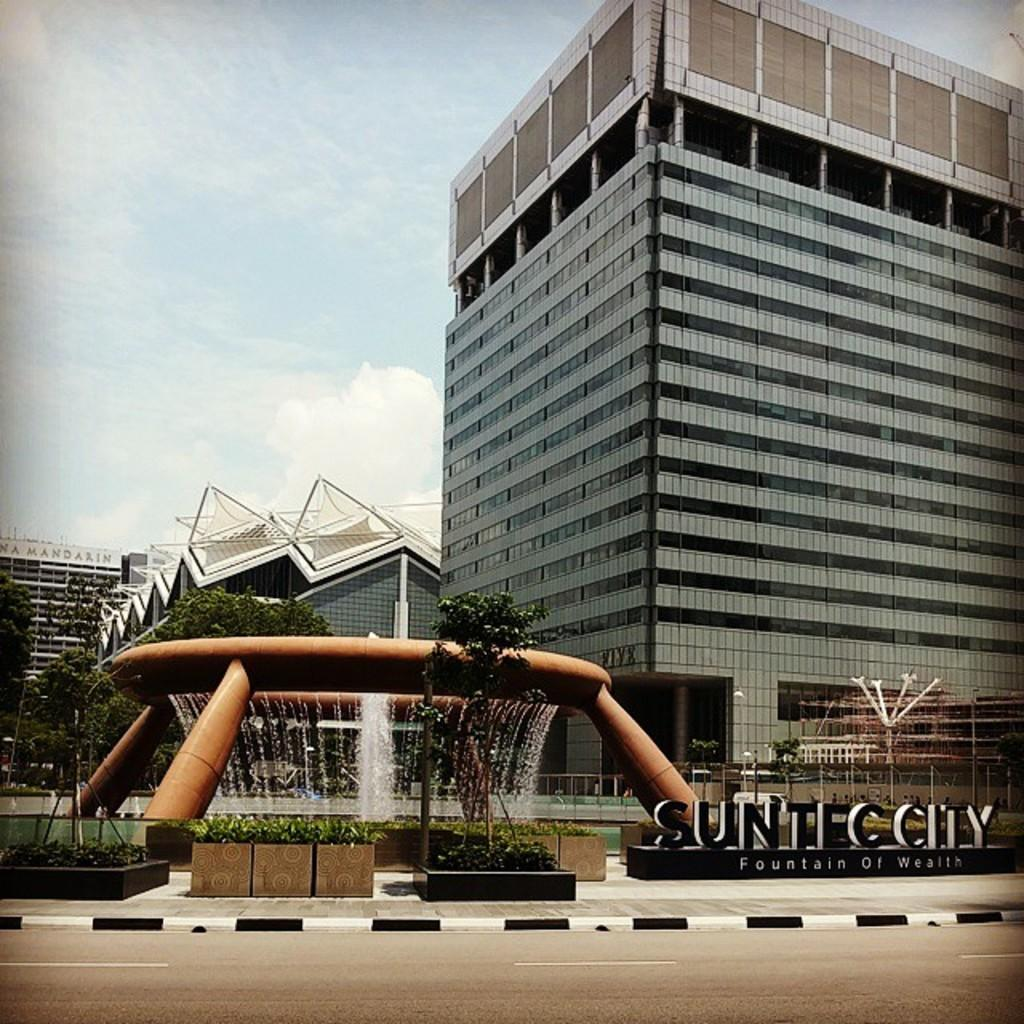What type of structures can be seen in the image? There are buildings in the image. What natural elements are present in the image? There are trees and plants in the image. What type of water feature is in the image? There is a fountain in the image. What part of the natural environment is visible in the image? The sky is visible in the image. What can be observed in the sky? There are clouds in the sky. Can you see any birds resting on the bed in the image? There is no bed present in the image, and therefore no birds resting on it. 